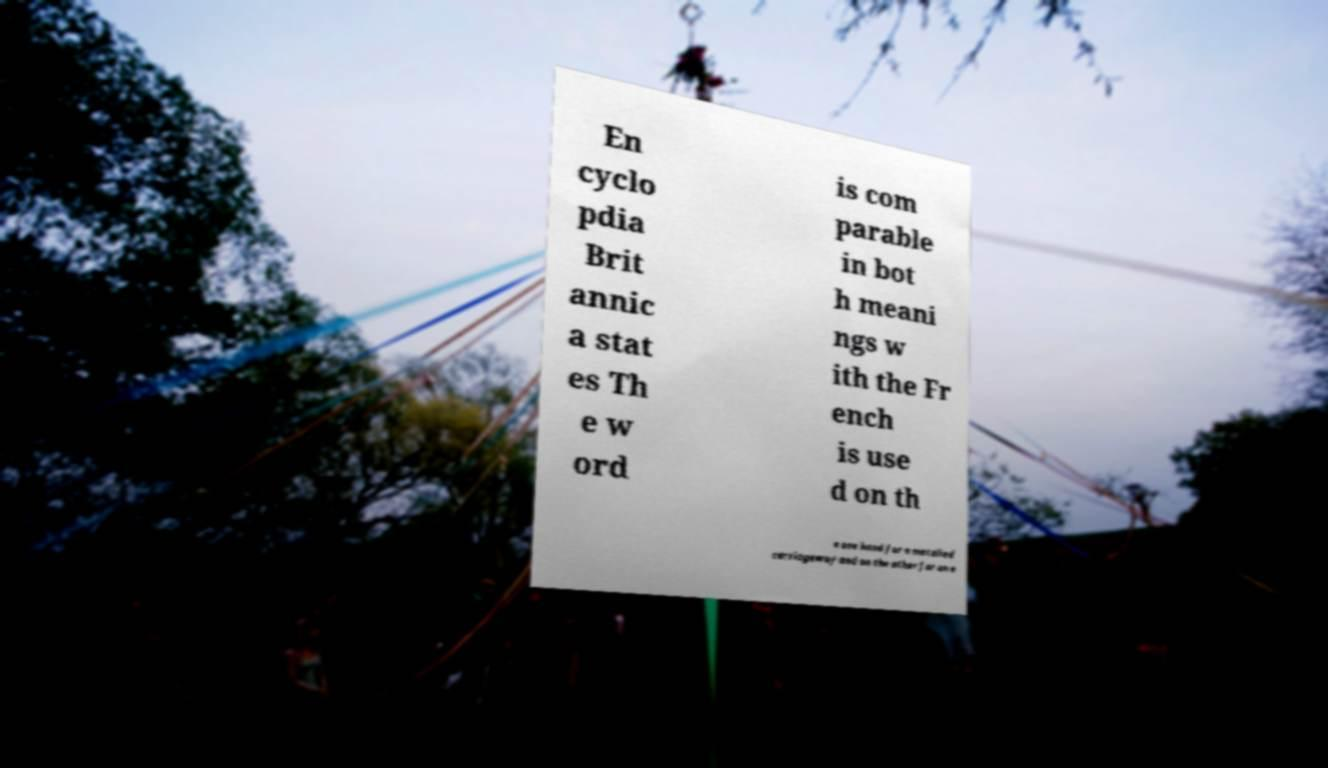Can you read and provide the text displayed in the image?This photo seems to have some interesting text. Can you extract and type it out for me? En cyclo pdia Brit annic a stat es Th e w ord is com parable in bot h meani ngs w ith the Fr ench is use d on th e one hand for a metalled carriageway and on the other for an e 